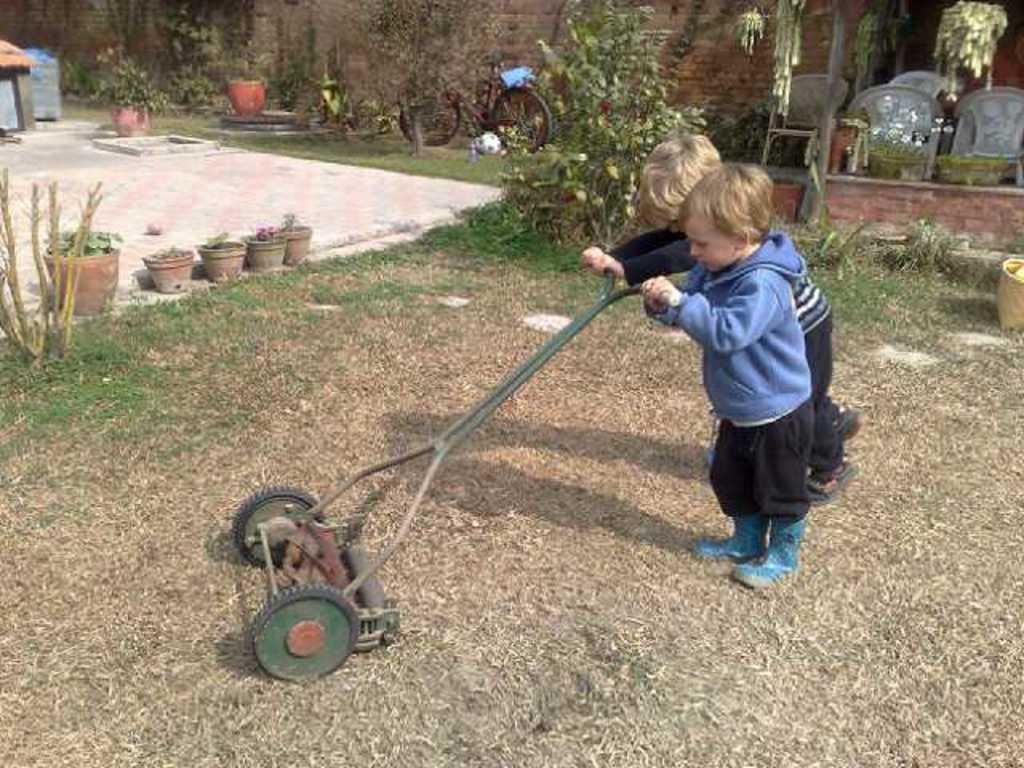What is the main object being used by the children in the image? There is an equipment in the image, and two children are holding it. What else can be seen in the image besides the equipment and children? There are plants in pots, a bicycle, and chairs in the image. What type of meal is being prepared on the equipment in the image? There is no meal being prepared on the equipment in the image; it is not a cooking appliance. 